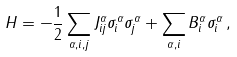<formula> <loc_0><loc_0><loc_500><loc_500>H = - \frac { 1 } { 2 } \sum _ { \alpha , i , j } J ^ { \alpha } _ { i j } \sigma ^ { \alpha } _ { i } \sigma ^ { \alpha } _ { j } + \sum _ { \alpha , i } B ^ { \alpha } _ { i } \sigma ^ { \alpha } _ { i } \, ,</formula> 